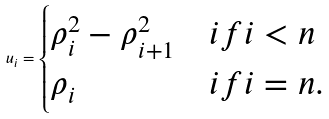<formula> <loc_0><loc_0><loc_500><loc_500>u _ { i } = \begin{cases} \rho _ { i } ^ { 2 } - \rho _ { i + 1 } ^ { 2 } & i f i < n \\ \rho _ { i } & i f i = n . \end{cases}</formula> 